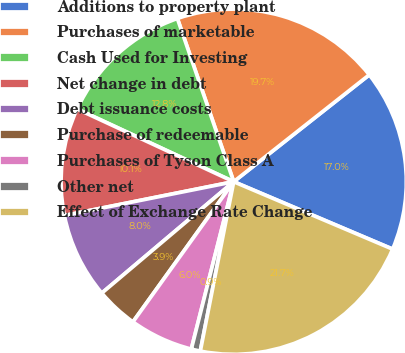Convert chart to OTSL. <chart><loc_0><loc_0><loc_500><loc_500><pie_chart><fcel>Additions to property plant<fcel>Purchases of marketable<fcel>Cash Used for Investing<fcel>Net change in debt<fcel>Debt issuance costs<fcel>Purchase of redeemable<fcel>Purchases of Tyson Class A<fcel>Other net<fcel>Effect of Exchange Rate Change<nl><fcel>17.01%<fcel>19.66%<fcel>12.79%<fcel>10.06%<fcel>8.02%<fcel>3.92%<fcel>5.97%<fcel>0.85%<fcel>21.71%<nl></chart> 